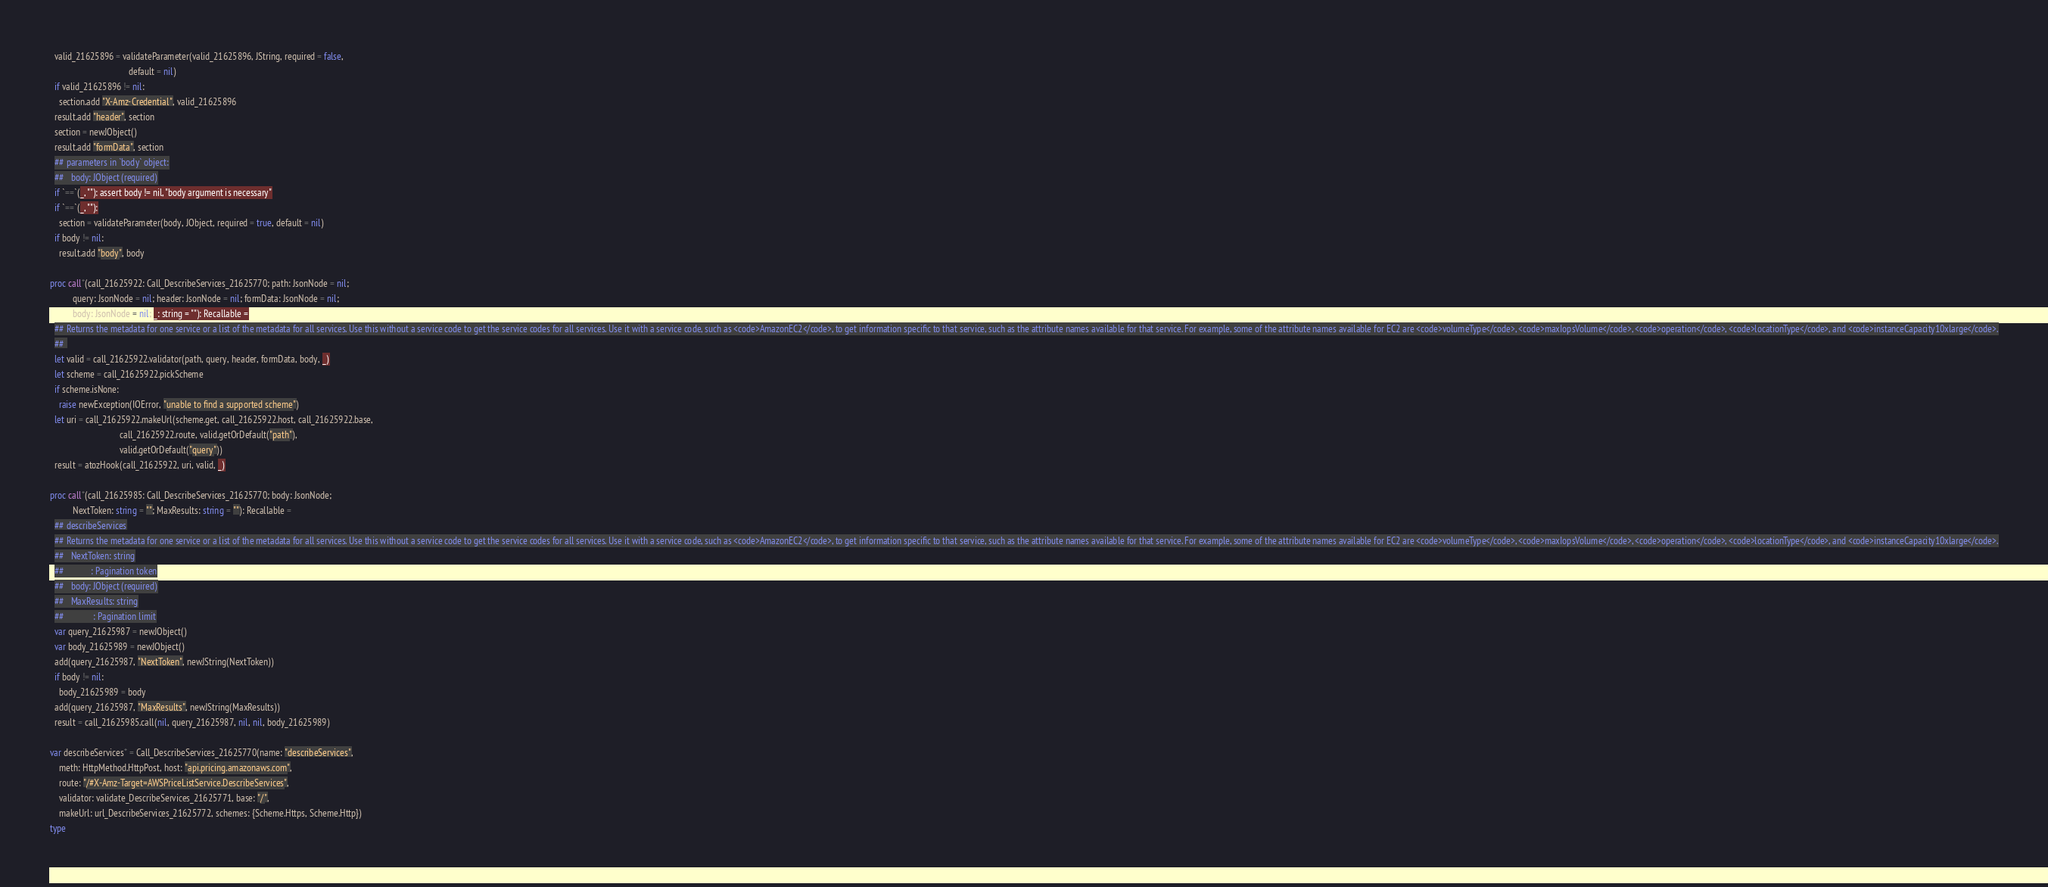<code> <loc_0><loc_0><loc_500><loc_500><_Nim_>  valid_21625896 = validateParameter(valid_21625896, JString, required = false,
                                   default = nil)
  if valid_21625896 != nil:
    section.add "X-Amz-Credential", valid_21625896
  result.add "header", section
  section = newJObject()
  result.add "formData", section
  ## parameters in `body` object:
  ##   body: JObject (required)
  if `==`(_, ""): assert body != nil, "body argument is necessary"
  if `==`(_, ""):
    section = validateParameter(body, JObject, required = true, default = nil)
  if body != nil:
    result.add "body", body

proc call*(call_21625922: Call_DescribeServices_21625770; path: JsonNode = nil;
          query: JsonNode = nil; header: JsonNode = nil; formData: JsonNode = nil;
          body: JsonNode = nil; _: string = ""): Recallable =
  ## Returns the metadata for one service or a list of the metadata for all services. Use this without a service code to get the service codes for all services. Use it with a service code, such as <code>AmazonEC2</code>, to get information specific to that service, such as the attribute names available for that service. For example, some of the attribute names available for EC2 are <code>volumeType</code>, <code>maxIopsVolume</code>, <code>operation</code>, <code>locationType</code>, and <code>instanceCapacity10xlarge</code>.
  ## 
  let valid = call_21625922.validator(path, query, header, formData, body, _)
  let scheme = call_21625922.pickScheme
  if scheme.isNone:
    raise newException(IOError, "unable to find a supported scheme")
  let uri = call_21625922.makeUrl(scheme.get, call_21625922.host, call_21625922.base,
                               call_21625922.route, valid.getOrDefault("path"),
                               valid.getOrDefault("query"))
  result = atozHook(call_21625922, uri, valid, _)

proc call*(call_21625985: Call_DescribeServices_21625770; body: JsonNode;
          NextToken: string = ""; MaxResults: string = ""): Recallable =
  ## describeServices
  ## Returns the metadata for one service or a list of the metadata for all services. Use this without a service code to get the service codes for all services. Use it with a service code, such as <code>AmazonEC2</code>, to get information specific to that service, such as the attribute names available for that service. For example, some of the attribute names available for EC2 are <code>volumeType</code>, <code>maxIopsVolume</code>, <code>operation</code>, <code>locationType</code>, and <code>instanceCapacity10xlarge</code>.
  ##   NextToken: string
  ##            : Pagination token
  ##   body: JObject (required)
  ##   MaxResults: string
  ##             : Pagination limit
  var query_21625987 = newJObject()
  var body_21625989 = newJObject()
  add(query_21625987, "NextToken", newJString(NextToken))
  if body != nil:
    body_21625989 = body
  add(query_21625987, "MaxResults", newJString(MaxResults))
  result = call_21625985.call(nil, query_21625987, nil, nil, body_21625989)

var describeServices* = Call_DescribeServices_21625770(name: "describeServices",
    meth: HttpMethod.HttpPost, host: "api.pricing.amazonaws.com",
    route: "/#X-Amz-Target=AWSPriceListService.DescribeServices",
    validator: validate_DescribeServices_21625771, base: "/",
    makeUrl: url_DescribeServices_21625772, schemes: {Scheme.Https, Scheme.Http})
type</code> 